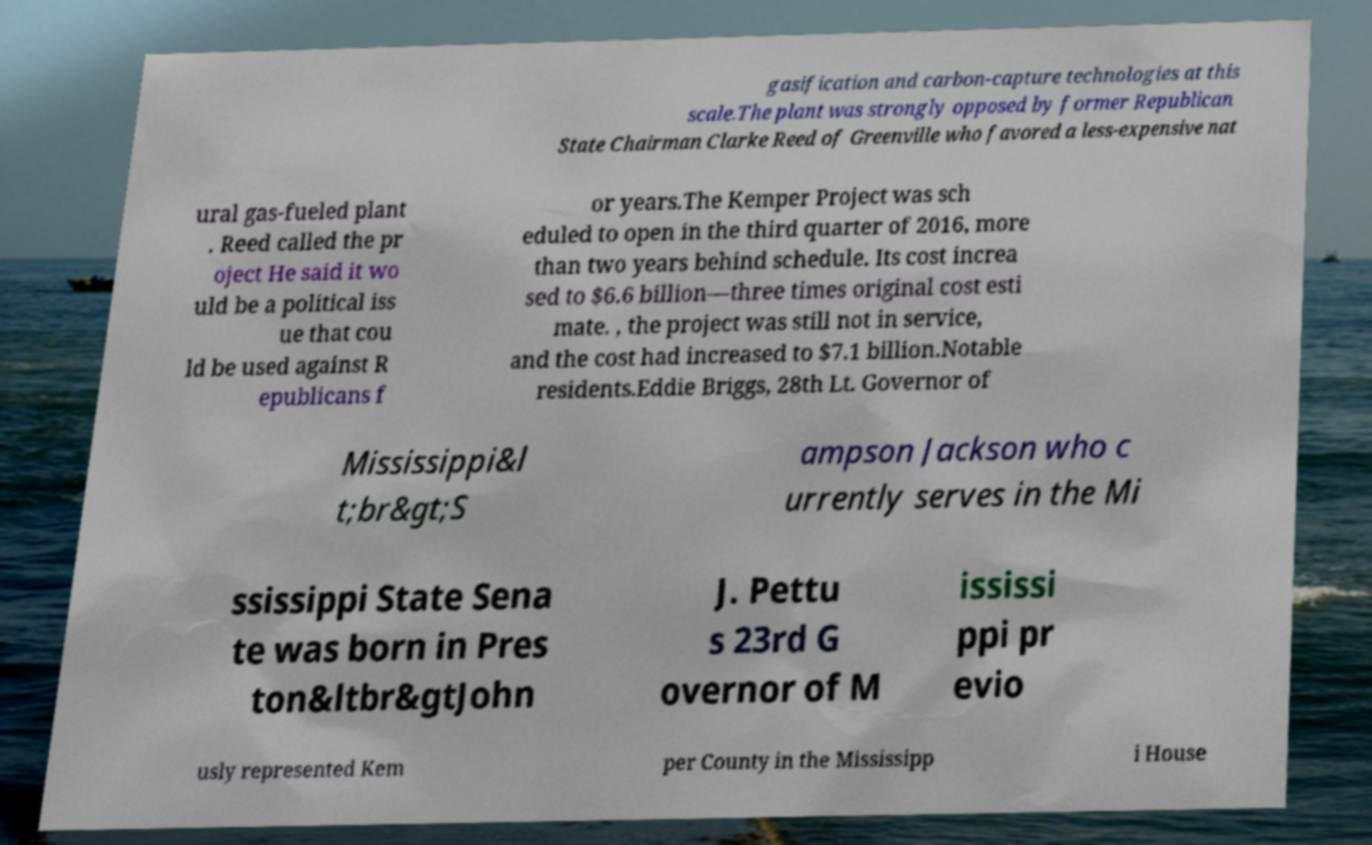For documentation purposes, I need the text within this image transcribed. Could you provide that? gasification and carbon-capture technologies at this scale.The plant was strongly opposed by former Republican State Chairman Clarke Reed of Greenville who favored a less-expensive nat ural gas-fueled plant . Reed called the pr oject He said it wo uld be a political iss ue that cou ld be used against R epublicans f or years.The Kemper Project was sch eduled to open in the third quarter of 2016, more than two years behind schedule. Its cost increa sed to $6.6 billion—three times original cost esti mate. , the project was still not in service, and the cost had increased to $7.1 billion.Notable residents.Eddie Briggs, 28th Lt. Governor of Mississippi&l t;br&gt;S ampson Jackson who c urrently serves in the Mi ssissippi State Sena te was born in Pres ton&ltbr&gtJohn J. Pettu s 23rd G overnor of M ississi ppi pr evio usly represented Kem per County in the Mississipp i House 